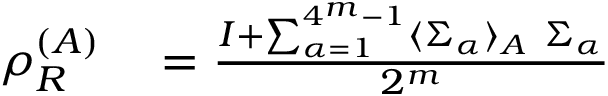<formula> <loc_0><loc_0><loc_500><loc_500>\begin{array} { r l } { \rho _ { R } ^ { ( A ) } } & = \frac { I + \sum _ { \alpha = 1 } ^ { 4 ^ { m } - 1 } \langle \Sigma _ { \alpha } \rangle _ { A } \Sigma _ { \alpha } } { 2 ^ { m } } } \end{array}</formula> 